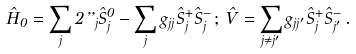<formula> <loc_0><loc_0><loc_500><loc_500>\hat { H } _ { 0 } = \sum _ { j } 2 \varepsilon _ { j } \hat { S } ^ { 0 } _ { j } - \sum _ { j } g _ { j j } \hat { S } ^ { + } _ { j } \hat { S } ^ { - } _ { j } \, ; \, \hat { V } = \sum _ { j \neq j ^ { \prime } } g _ { j j ^ { \prime } } \hat { S } ^ { + } _ { j } \hat { S } ^ { - } _ { j ^ { \prime } } \, .</formula> 